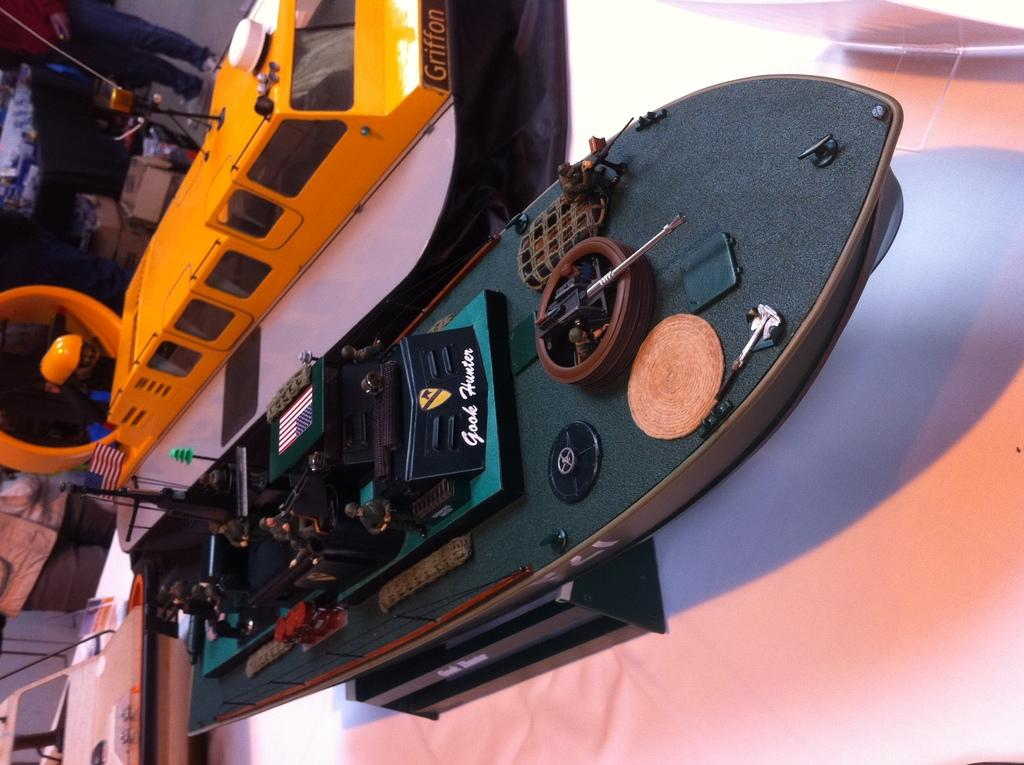What type of watercraft can be seen in the image? There is a boat and a ship in the image. What is the color of the surface in the image? The image has a white surface. What objects are present at the back of the image? There are carton boxes at the back of the image. Can you describe the person in the image? There is a man standing on the ground in the image. What type of leather is being used to cover the ship in the image? There is no leather present in the image, and the ship's covering is not mentioned. What is the aftermath of the storm in the image? There is no mention of a storm or any aftermath in the image. 